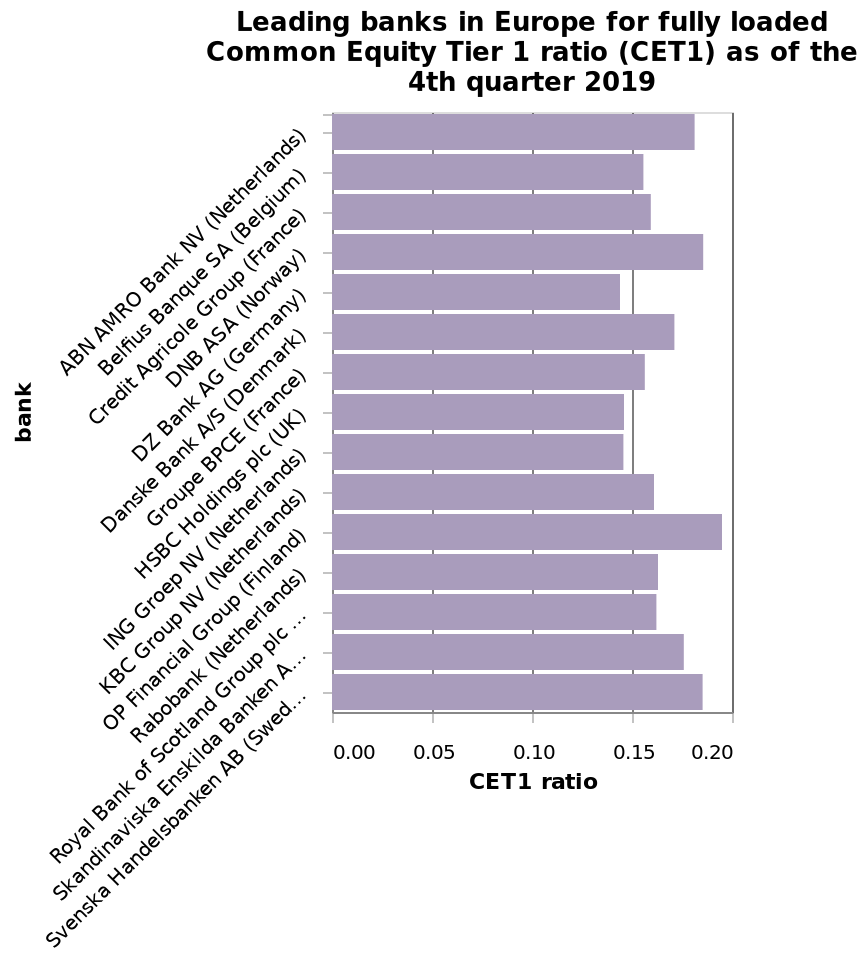<image>
What time period does this bar chart refer to? This bar chart refers to the 4th quarter of 2019. 